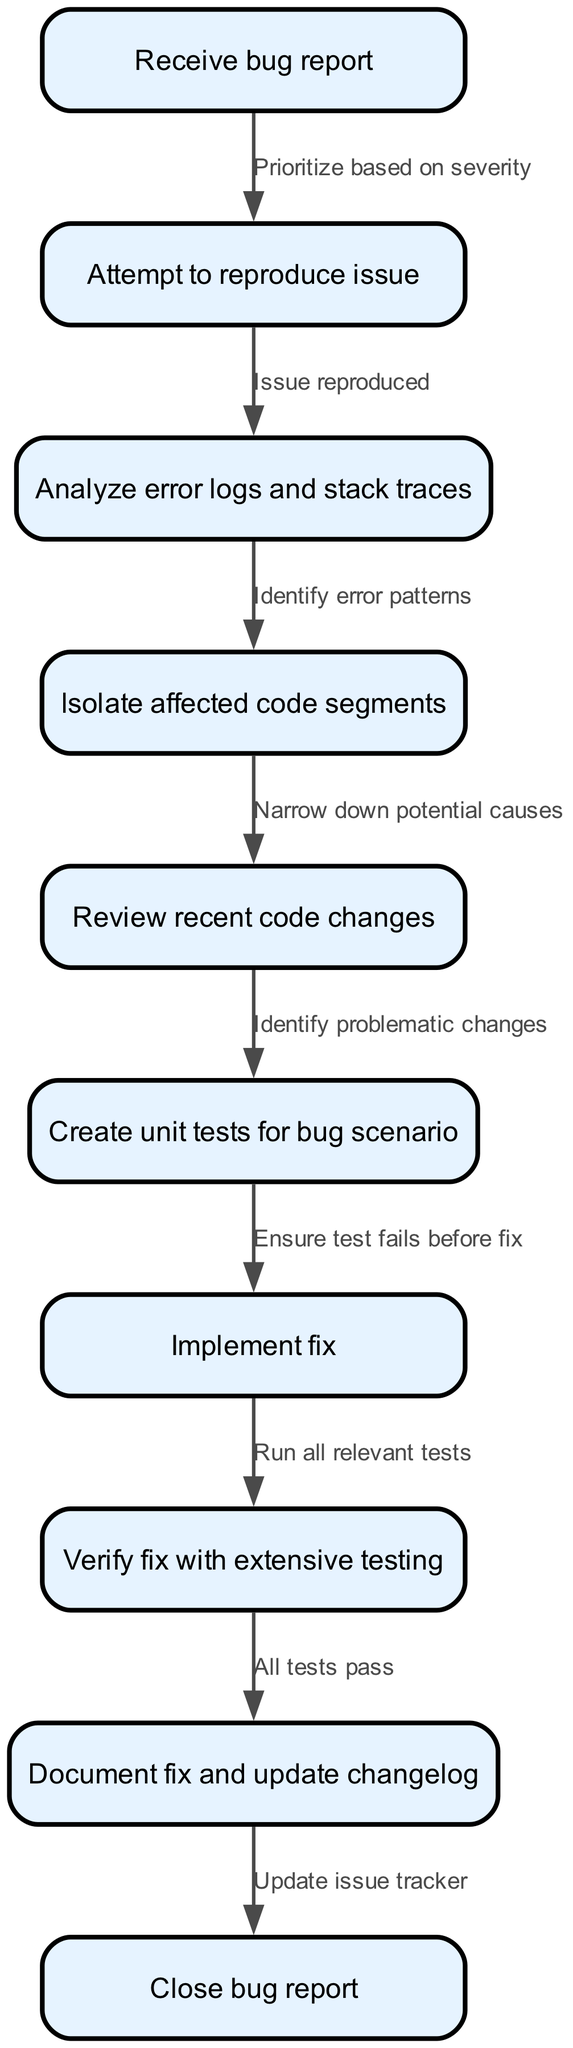What is the first node in the diagram? The first node is "Receive bug report", which indicates the starting point of the debugging workflow.
Answer: Receive bug report How many nodes are in the diagram? To find the number of nodes, we can count each node listed in the data section. There are ten nodes total.
Answer: 10 What does the edge from "analyze" to "isolate" represent? The edge represents the transition from analyzing error logs to isolating the affected code segments, indicating a progression in the debugging process.
Answer: Identify error patterns What is the last step before closing the bug report? The last step is to update the issue tracker, which follows the documentation process of the fix.
Answer: Update issue tracker Which node follows the "test" node? The "fix" node directly follows the "test" node, indicating that after creating unit tests, the next action is to implement a fix.
Answer: Implement fix What action is taken after verifying the fix? After verifying the fix, the next action is to document the fix and update the changelog.
Answer: Document fix and update changelog What criterion is used to prioritize the bug reports? The criterion used to prioritize is based on the severity of the issues reported.
Answer: Based on severity How is the unit test validated in relation to the bug fix? The unit test is validated by ensuring it fails before the implementation of the fix, establishing that the test effectively checks for the bug.
Answer: Ensure test fails before fix Why is it important to review recent code changes? Reviewing recent code changes is critical to identify problematic changes that could have led to the bug, which directs the debugging efforts effectively.
Answer: Identify problematic changes 